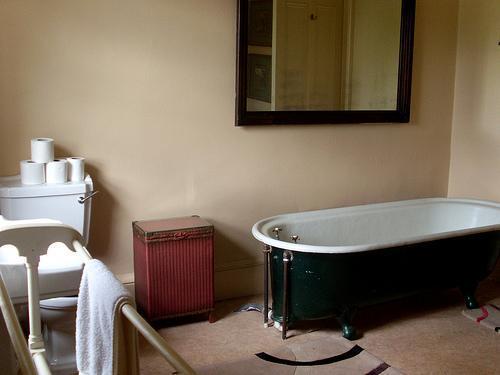How many rolls of toilet paper are there?
Give a very brief answer. 4. 